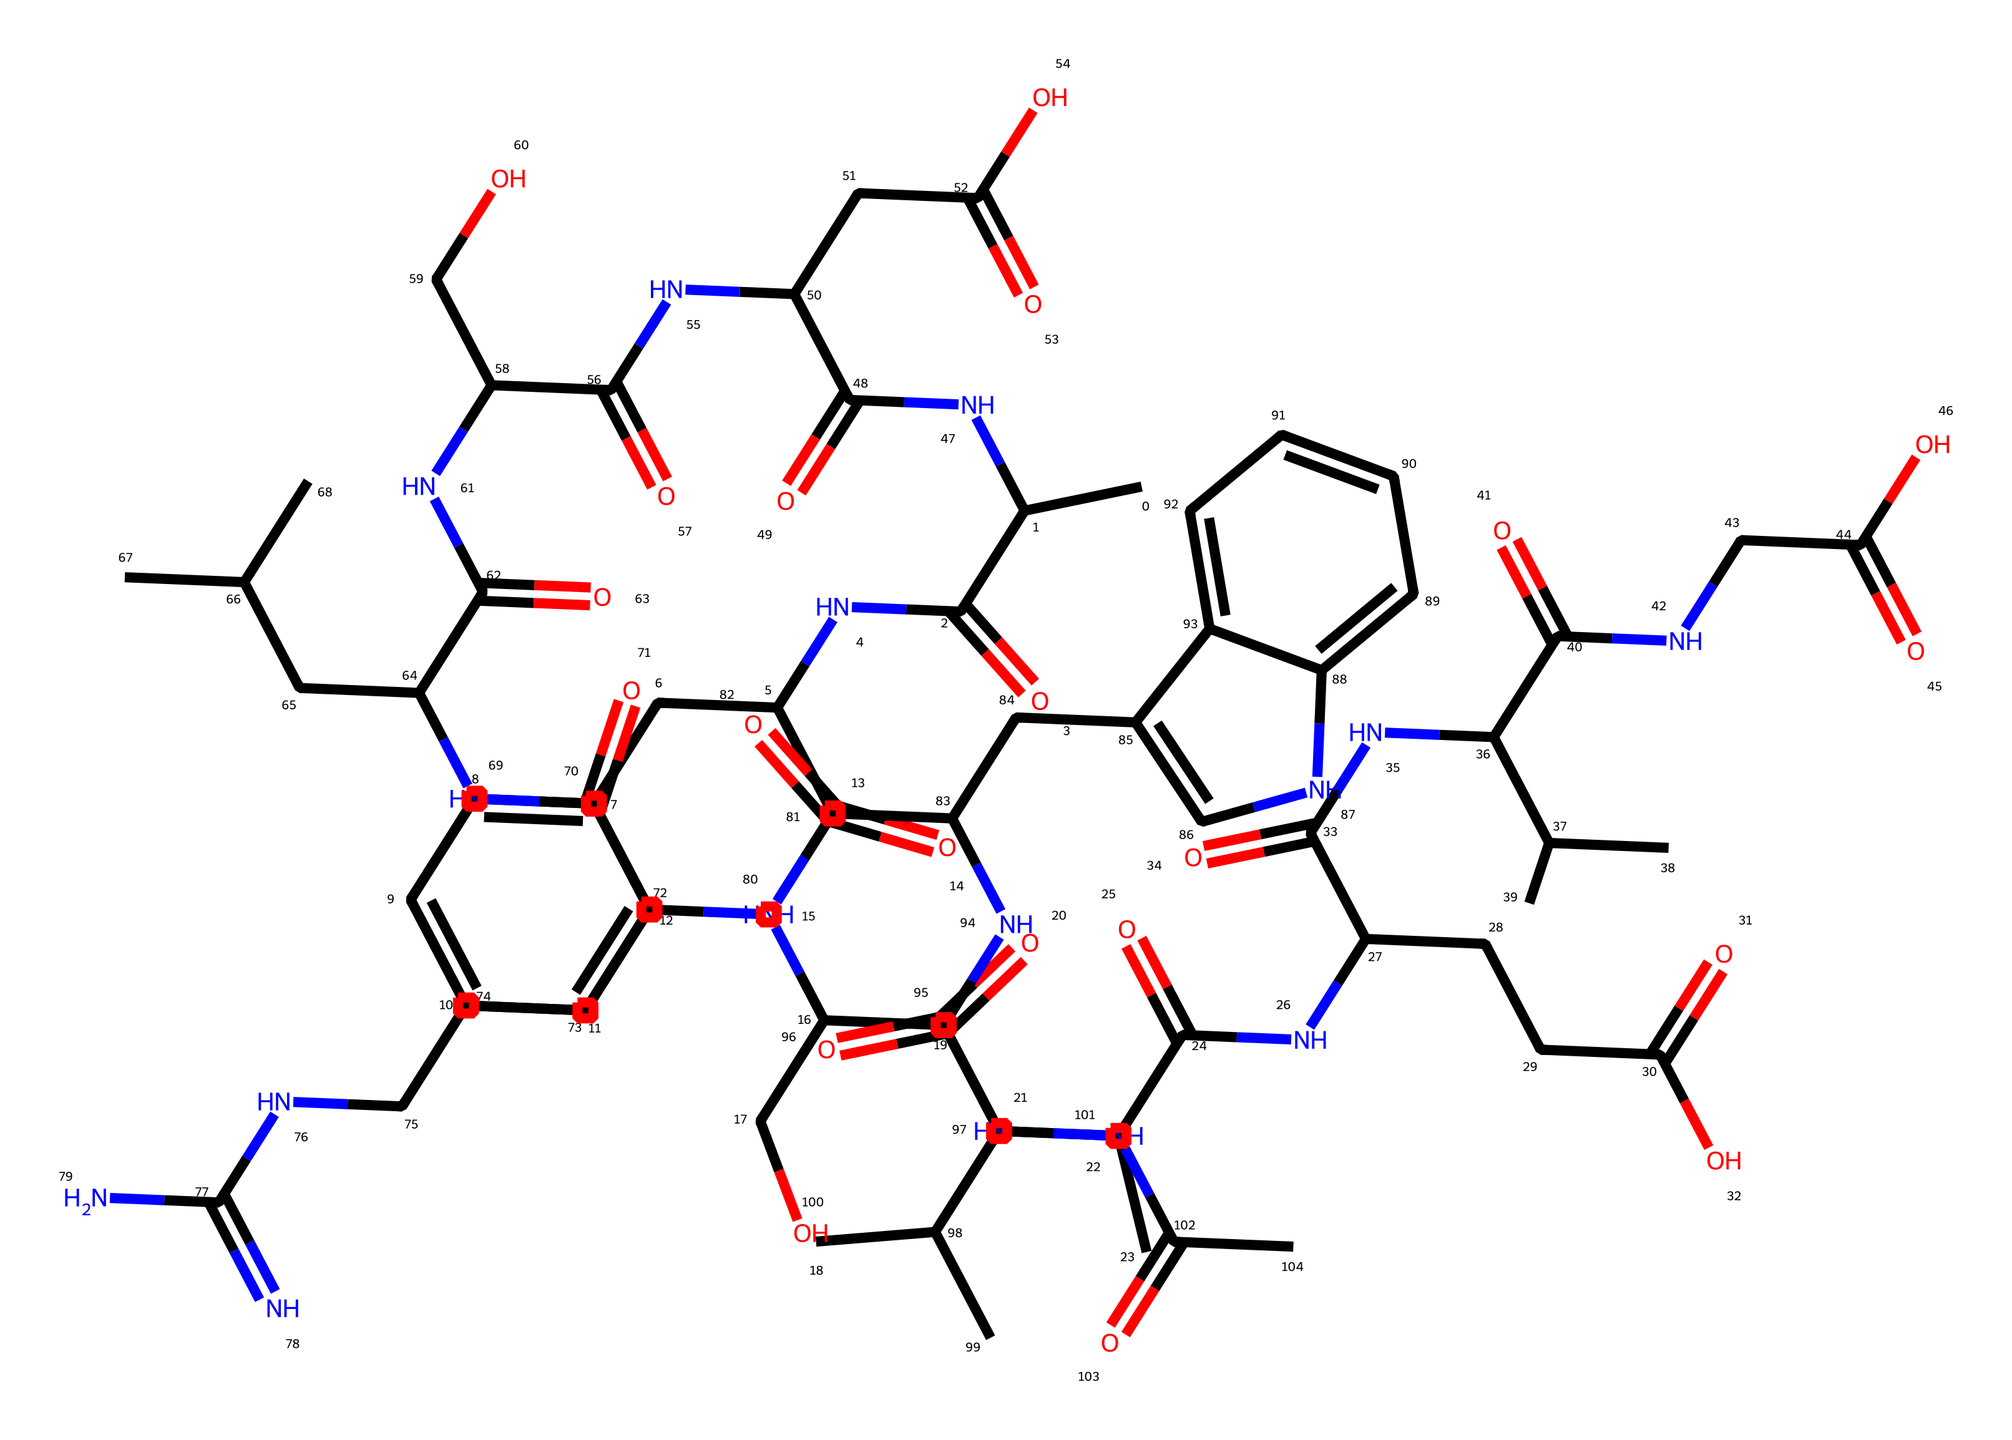What is the molecular formula of the compound represented by this SMILES? The SMILES representation can be analyzed to count the carbon (C), hydrogen (H), nitrogen (N), and oxygen (O) atoms. By breaking down the SMILES, we find there are 42 carbon atoms, 62 hydrogen atoms, 10 nitrogen atoms, and 8 oxygen atoms. Therefore, the molecular formula is C42H62N10O8.
Answer: C42H62N10O8 How many nitrogen atoms are present in the structure? By examining the SMILES, we identify each nitrogen atom (N) within the sequence. Counting these, we find a total of 10 nitrogen atoms.
Answer: 10 What type of linkage can be observed in this lipid structure? The presence of amide bonds (C(=O)N) is a distinctive feature in this lipid’s structure, linking amino acids and contributing to its collagen characteristics as part of the molecular structure.
Answer: amide What is the predominant functional group in this compound? The molecule has several carbonyl groups (C=O) throughout, characteristic of ketones and amides. Upon review, the functional aspect of the structure points out the amide as the primary functional group forming part of the polypeptide chains typical in collagen.
Answer: amide How many distinct side chains can be detected in the chemical structure? By analyzing the structure, we identify various substituents branching from the central polypeptide backbone. They include three distinct side chains located throughout that add diversity to the overall molecule.
Answer: 3 What role do these lipid structures typically play in historical preservation? The collagen presented in leather artifacts binds moisture and can significantly contribute to the structural integrity and preservation of the artifact during aging or environmental exposure.
Answer: structural integrity 